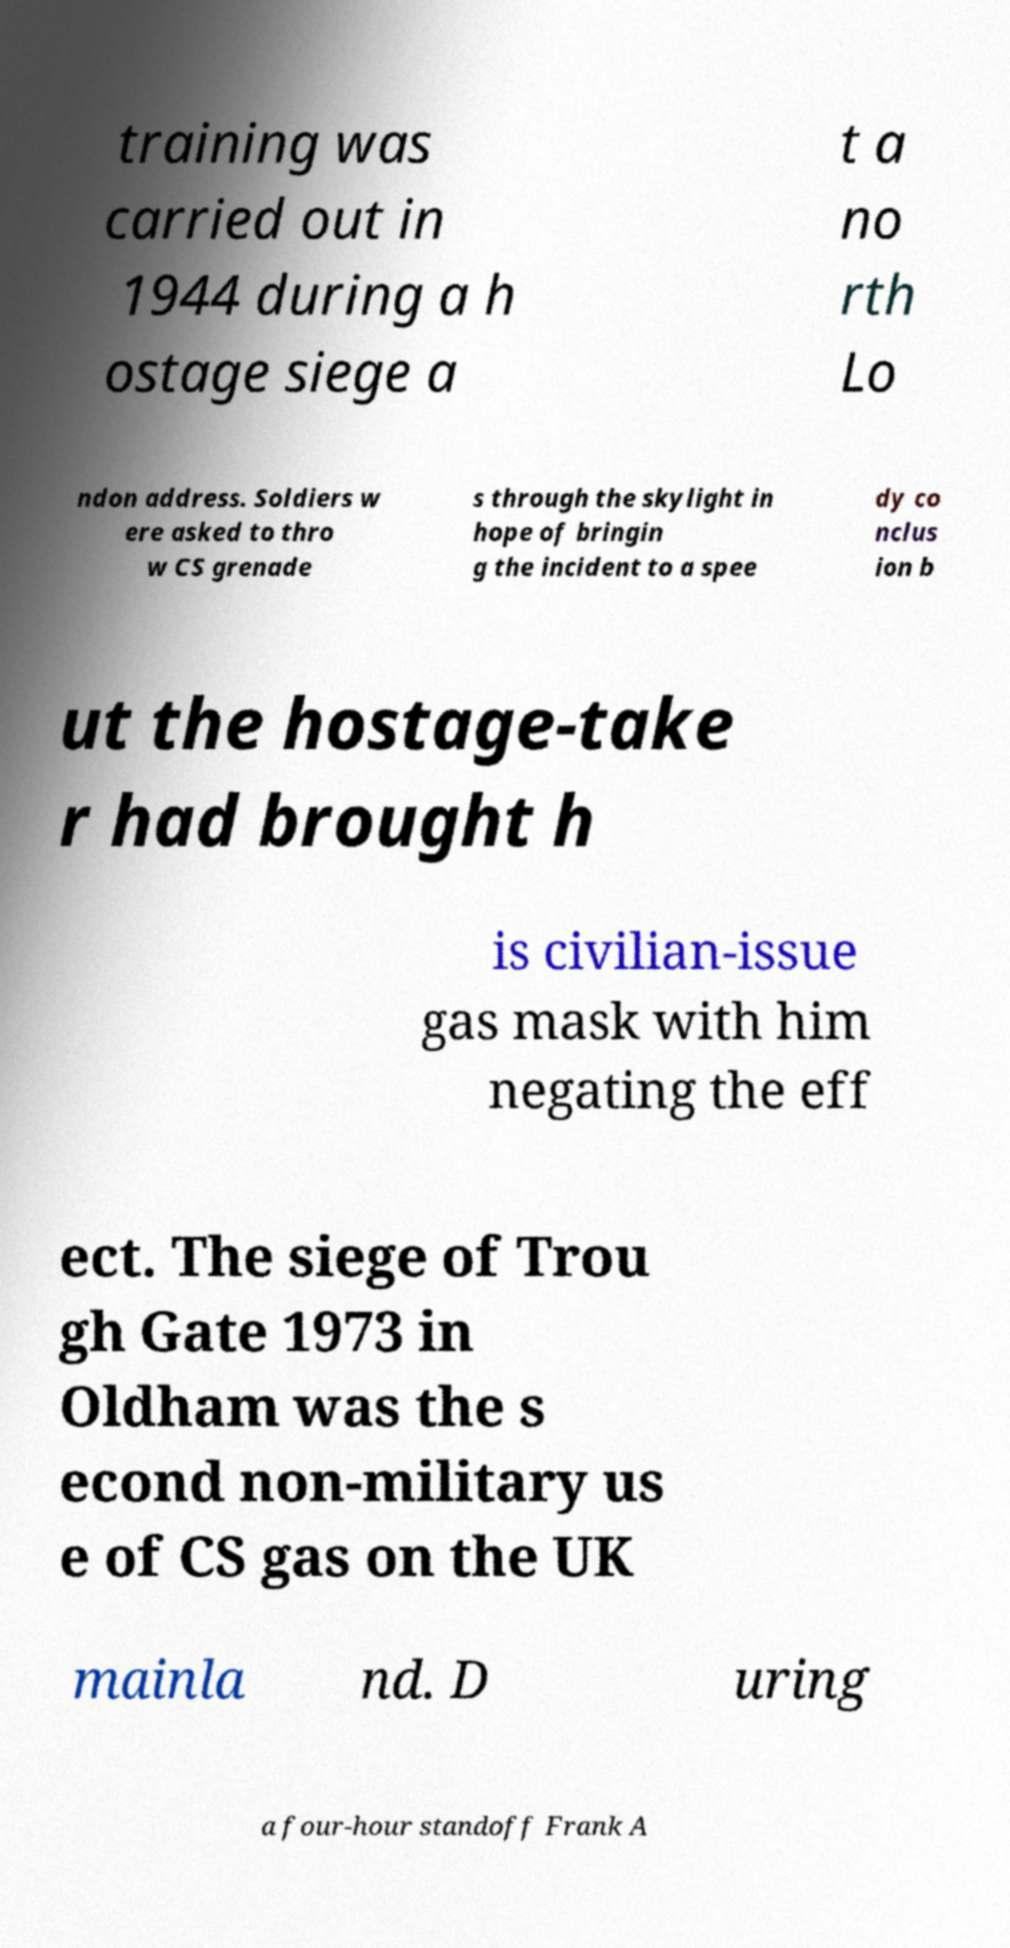What messages or text are displayed in this image? I need them in a readable, typed format. training was carried out in 1944 during a h ostage siege a t a no rth Lo ndon address. Soldiers w ere asked to thro w CS grenade s through the skylight in hope of bringin g the incident to a spee dy co nclus ion b ut the hostage-take r had brought h is civilian-issue gas mask with him negating the eff ect. The siege of Trou gh Gate 1973 in Oldham was the s econd non-military us e of CS gas on the UK mainla nd. D uring a four-hour standoff Frank A 